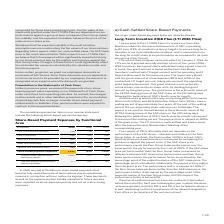According to Sap Ag's financial document, Why did the €79 million in share-based payments become fully vested? because of terminations due to operational reasons in connection with our restructuring plan. These payments as well as the expense portion initially allocated to future services were classified as share-based payments and not as restructuring expenses.. The document states: "became fully vested because of terminations due to operational reasons in connection with our restructuring plan. These payments as well as the expens..." Also, What were the Share-based payment expenses in 2019? According to the financial document, 1,835 (in millions). The relevant text states: "Share-based payment expenses 1,835 830 1,120..." Also, In which years were the Share-Based Payment Expenses by Functional Area calculated? The document contains multiple relevant values: 2019, 2018, 2017. From the document: "€ millions 2019 2018 2017 € millions 2019 2018 2017 € millions 2019 2018 2017..." Additionally, In which year was the Cost of cloud and software the largest? According to the financial document, 2019. The relevant text states: "€ millions 2019 2018 2017..." Also, can you calculate: What was the change in Cost of cloud and software in 2019 from 2018? Based on the calculation: 138-78, the result is 60 (in millions). This is based on the information: "Cost of cloud and software 138 78 115 Cost of cloud and software 138 78 115..." The key data points involved are: 138, 78. Also, can you calculate: What was the percentage change in Cost of cloud and software in 2019 from 2018? To answer this question, I need to perform calculations using the financial data. The calculation is: (138-78)/78, which equals 76.92 (percentage). This is based on the information: "Cost of cloud and software 138 78 115 Cost of cloud and software 138 78 115..." The key data points involved are: 138, 78. 